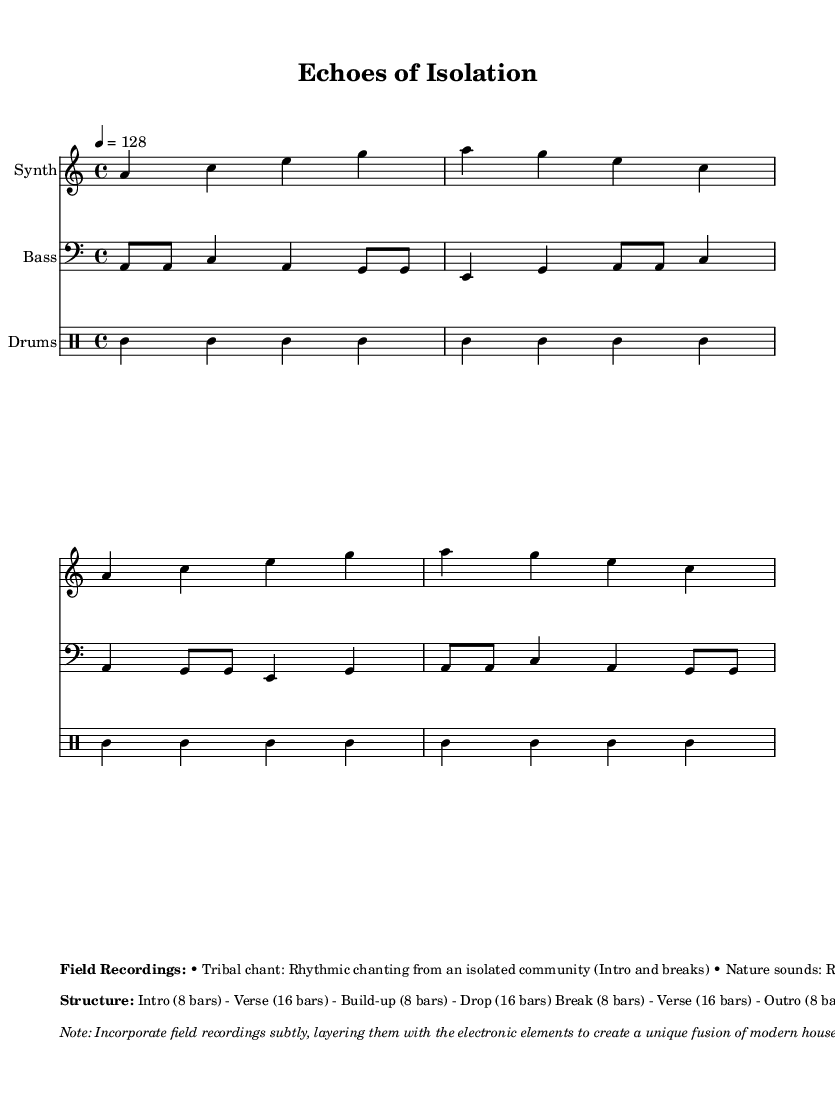What is the key signature of this music? The key signature is indicated in the global section and is A minor, which has no sharps or flats.
Answer: A minor What is the time signature of this music? The time signature is found in the global section as well and it is 4/4, which means there are four beats in a measure.
Answer: 4/4 What is the tempo of this music? The tempo is indicated in the global section, expressed as 4 = 128, meaning it plays at 128 beats per minute.
Answer: 128 How many bars are in the intro section? The structure section shows the intro spans 8 bars based on the breakdown provided.
Answer: 8 bars What is the primary genre of this piece? The overall context and the title "Echoes of Isolation" suggest that it is a blend of house music with elements of field recordings from isolated communities, defining its unique genre.
Answer: House During which section are the tribal chants prominently featured? The markup mentions that the tribal chant is used during the Intro and breaks, indicating its prominent use in those sections.
Answer: Intro and breaks How is the role of field recordings in this piece described? The markup emphasizes that the field recordings are to be incorporated subtly, layering them with electronic elements to enhance the fusion of sounds.
Answer: Subtly layered 